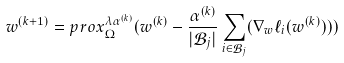<formula> <loc_0><loc_0><loc_500><loc_500>w ^ { ( k + 1 ) } = p r o x ^ { \lambda \alpha ^ { ( k ) } } _ { \Omega } ( w ^ { ( k ) } - \frac { \alpha ^ { ( k ) } } { | \mathcal { B } _ { j } | } \sum _ { i \in \mathcal { B } _ { j } } ( \nabla _ { w } \ell _ { i } ( w ^ { ( k ) } ) ) )</formula> 